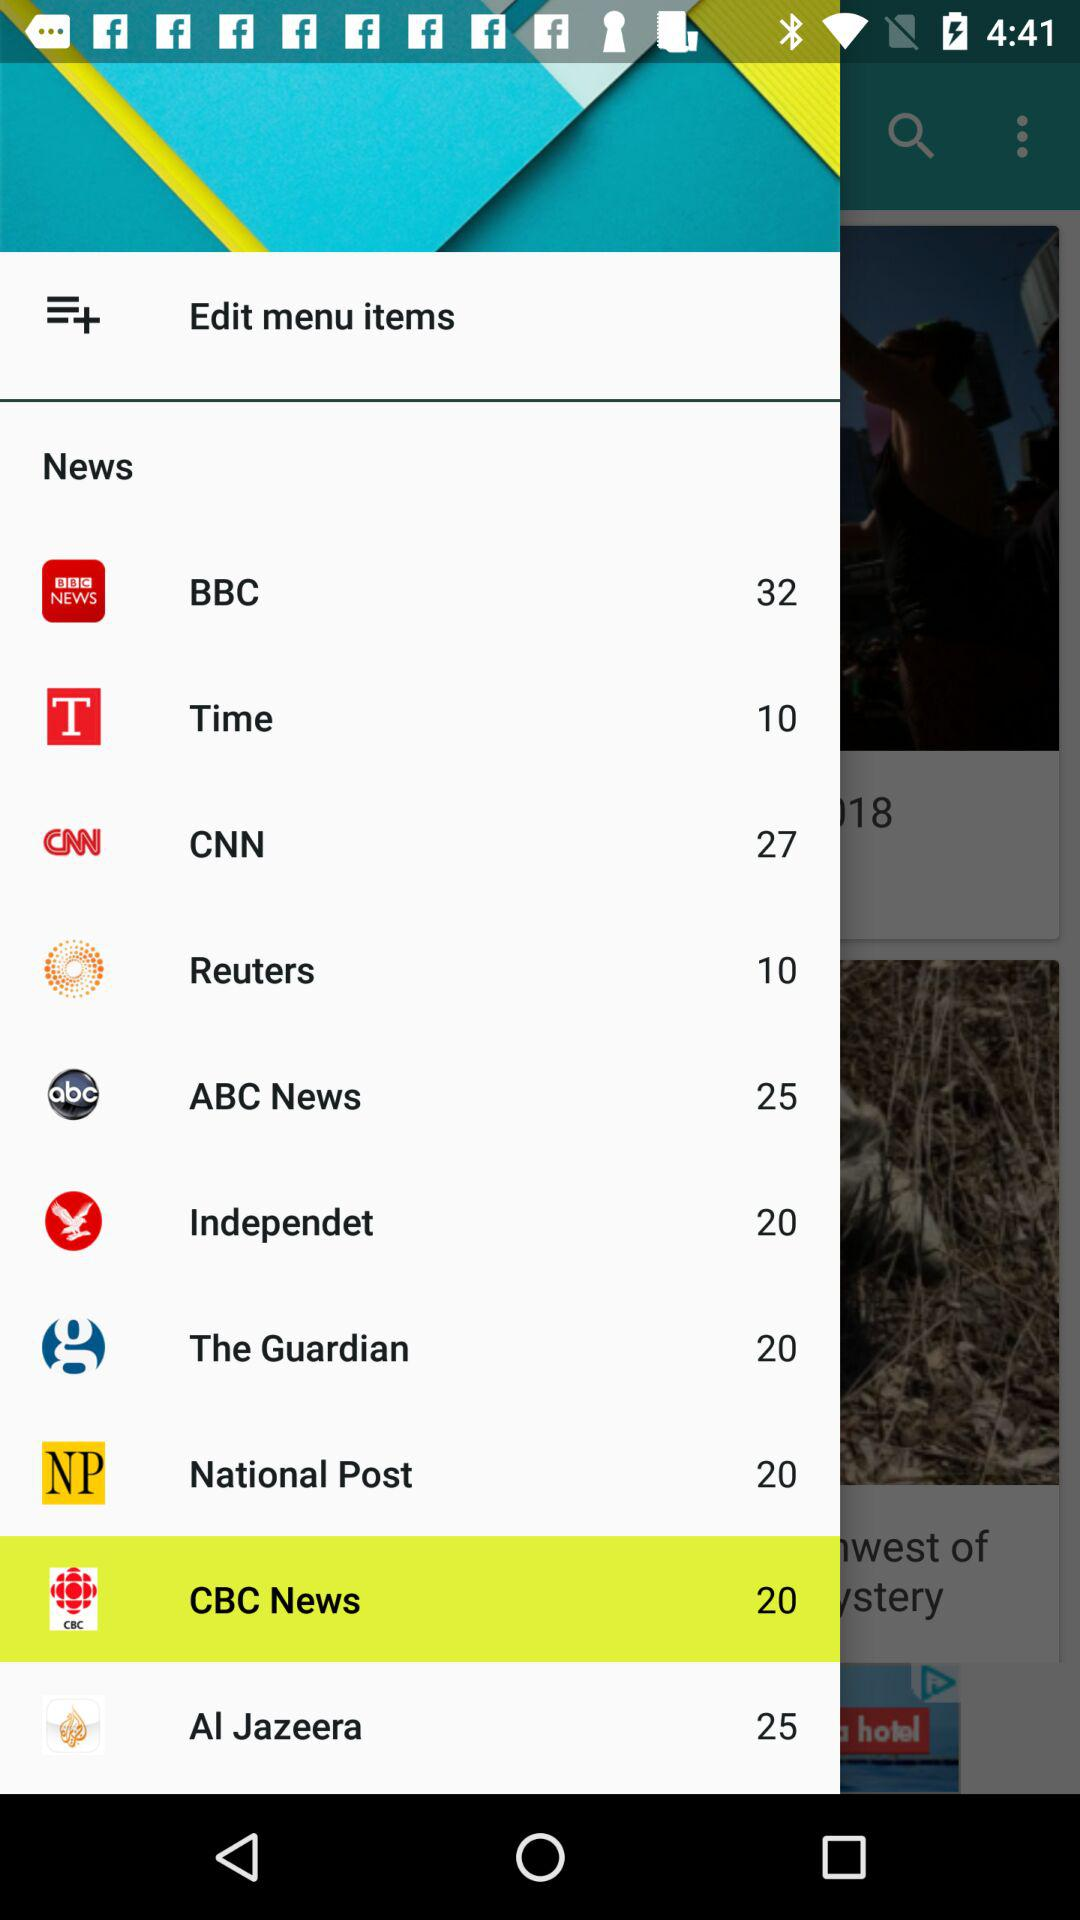What is the count for the news on the Reuters channel? The count for the news on the Reuters channel is 10. 